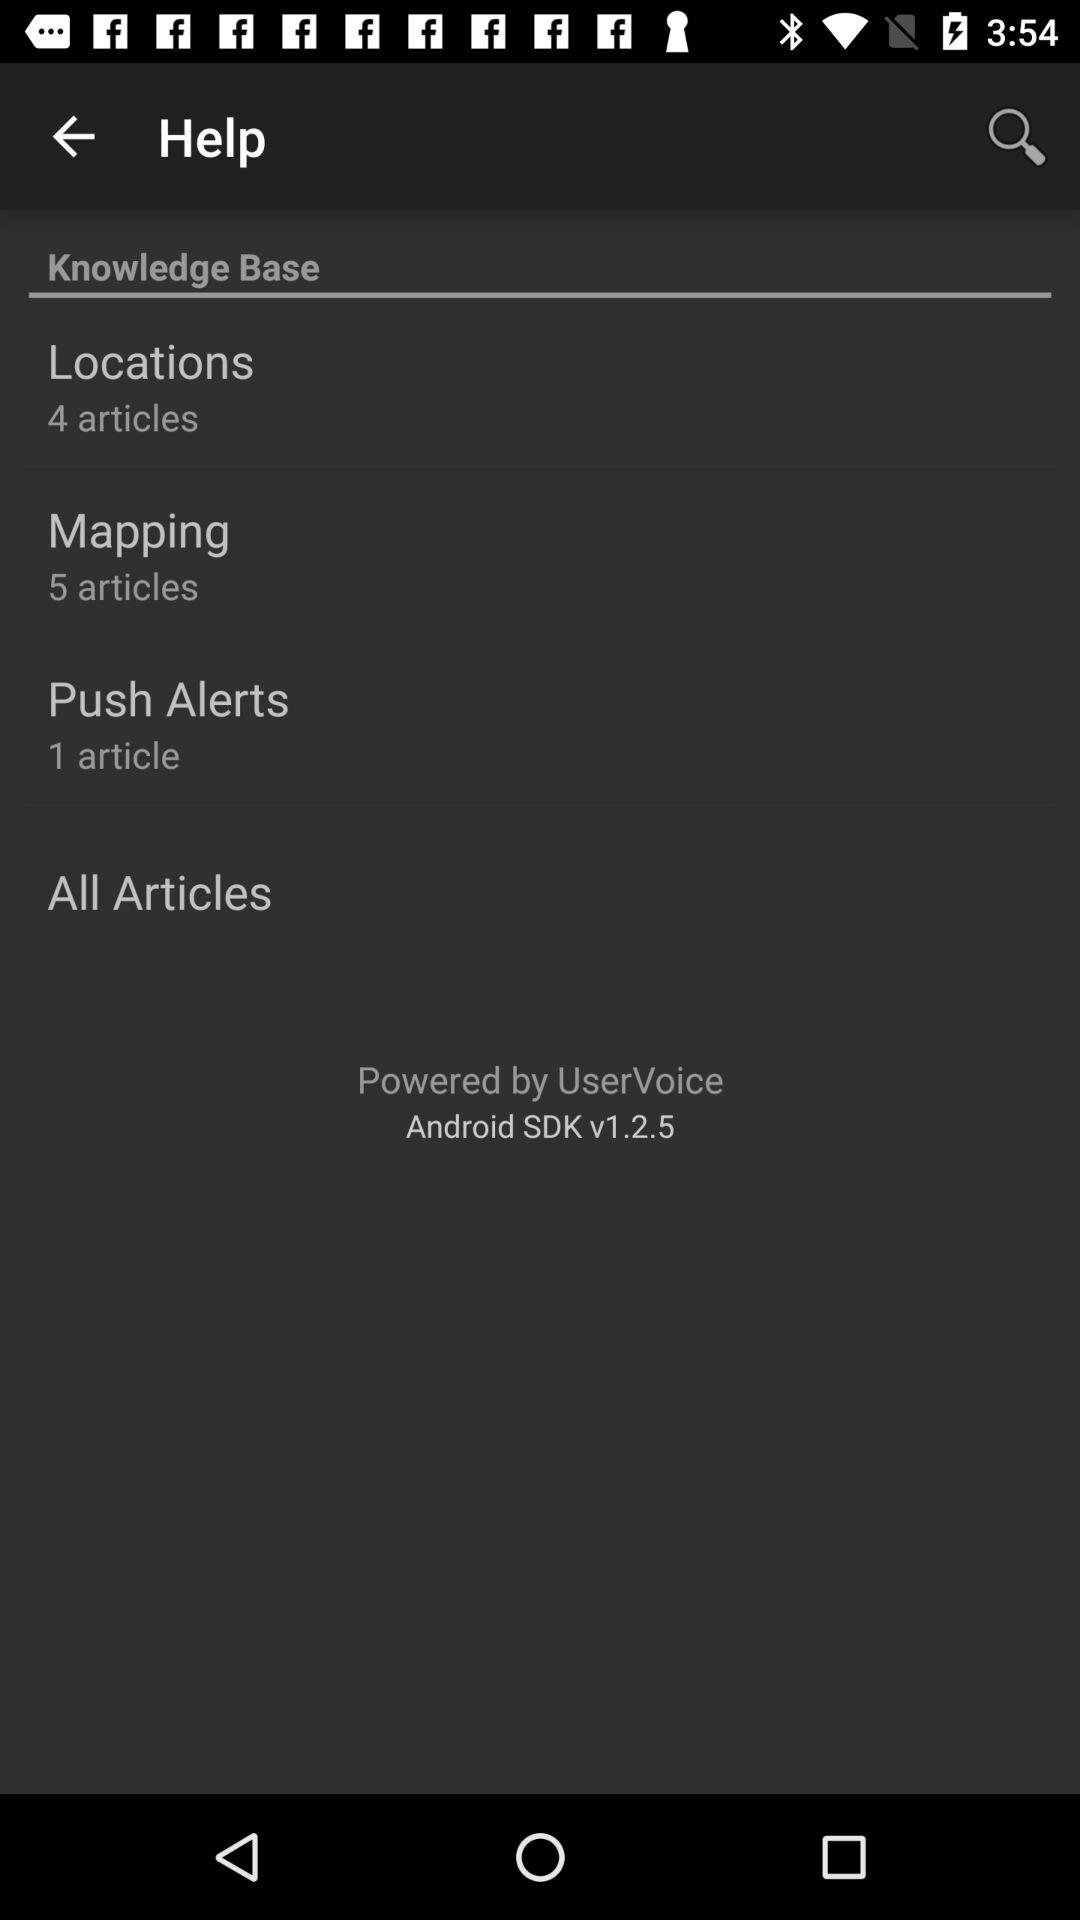How many articles are there in total on all the pages?
Answer the question using a single word or phrase. 10 